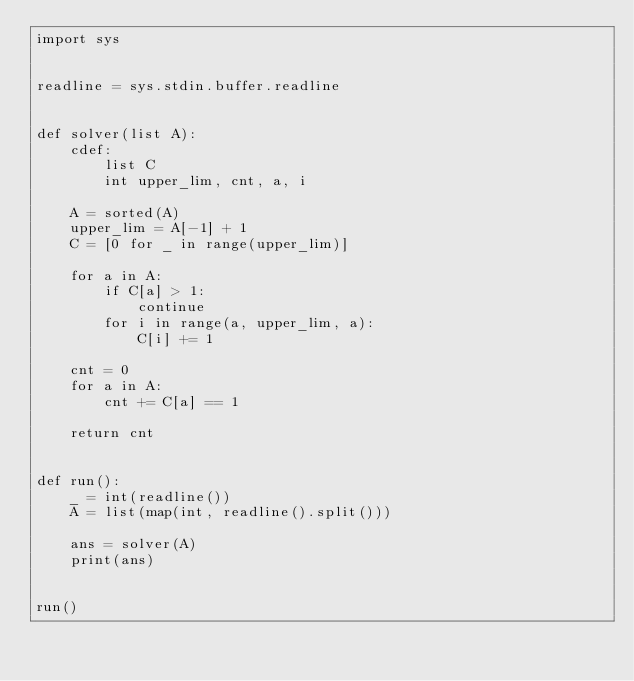Convert code to text. <code><loc_0><loc_0><loc_500><loc_500><_Cython_>import sys


readline = sys.stdin.buffer.readline


def solver(list A):
    cdef:
        list C
        int upper_lim, cnt, a, i

    A = sorted(A)
    upper_lim = A[-1] + 1
    C = [0 for _ in range(upper_lim)]

    for a in A:
        if C[a] > 1:
            continue
        for i in range(a, upper_lim, a):
            C[i] += 1

    cnt = 0
    for a in A:
        cnt += C[a] == 1

    return cnt


def run():
    _ = int(readline())
    A = list(map(int, readline().split()))

    ans = solver(A)
    print(ans)


run()
</code> 